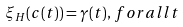Convert formula to latex. <formula><loc_0><loc_0><loc_500><loc_500>\xi _ { H } ( c ( t ) ) = \gamma ( t ) , \, f o r a l l t</formula> 